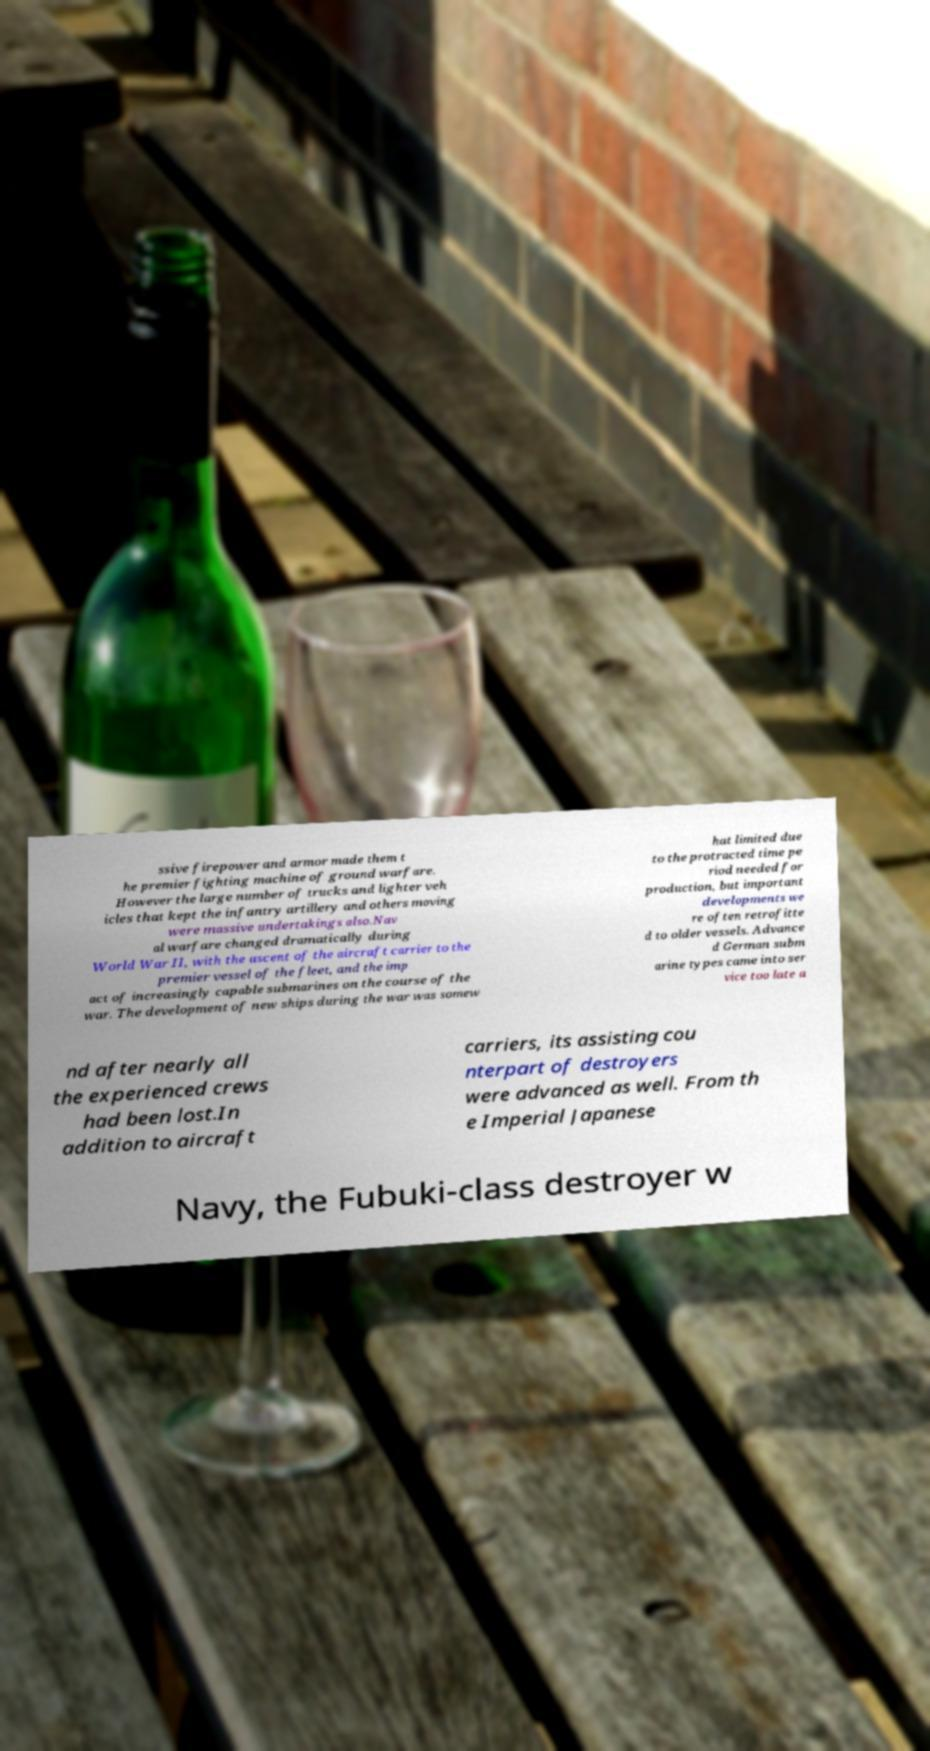I need the written content from this picture converted into text. Can you do that? ssive firepower and armor made them t he premier fighting machine of ground warfare. However the large number of trucks and lighter veh icles that kept the infantry artillery and others moving were massive undertakings also.Nav al warfare changed dramatically during World War II, with the ascent of the aircraft carrier to the premier vessel of the fleet, and the imp act of increasingly capable submarines on the course of the war. The development of new ships during the war was somew hat limited due to the protracted time pe riod needed for production, but important developments we re often retrofitte d to older vessels. Advance d German subm arine types came into ser vice too late a nd after nearly all the experienced crews had been lost.In addition to aircraft carriers, its assisting cou nterpart of destroyers were advanced as well. From th e Imperial Japanese Navy, the Fubuki-class destroyer w 